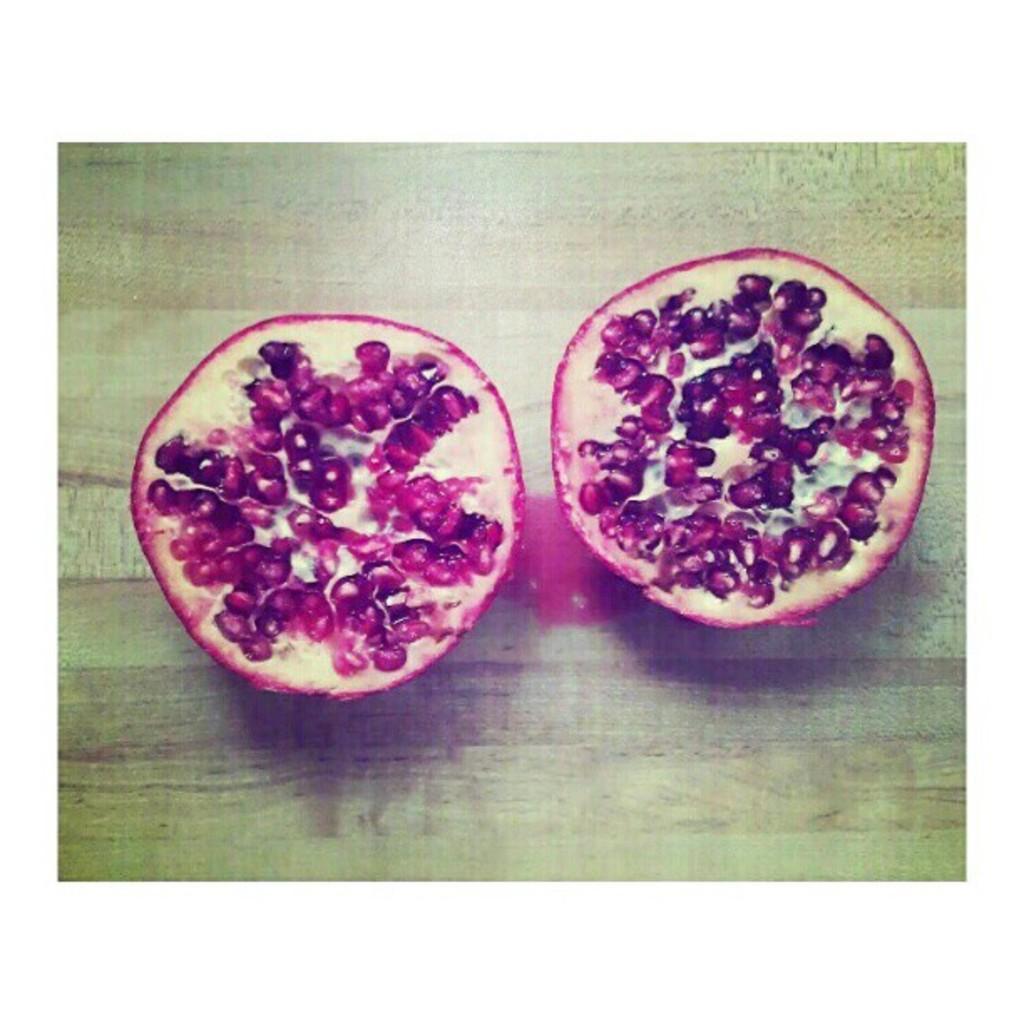Please provide a concise description of this image. In this image we can see two slices of a pomegranate on a wooden surface. 